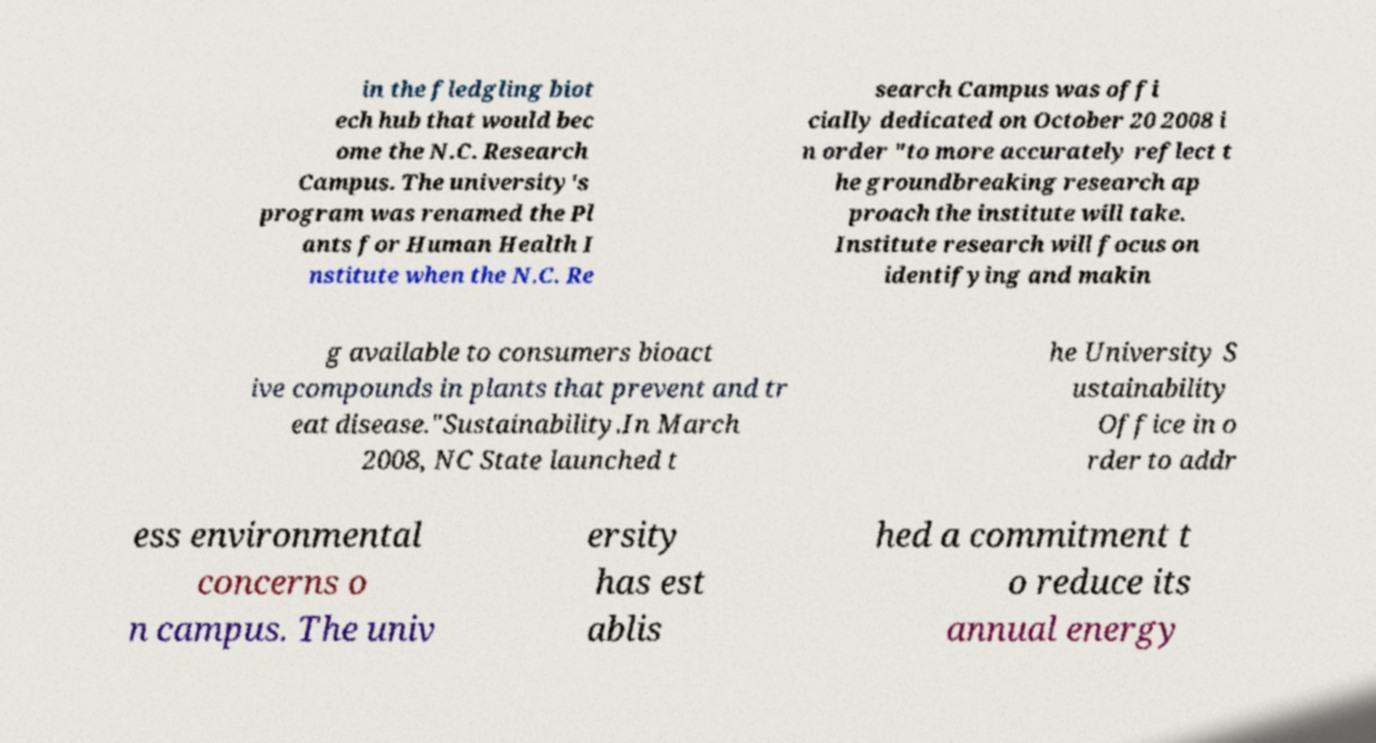For documentation purposes, I need the text within this image transcribed. Could you provide that? in the fledgling biot ech hub that would bec ome the N.C. Research Campus. The university's program was renamed the Pl ants for Human Health I nstitute when the N.C. Re search Campus was offi cially dedicated on October 20 2008 i n order "to more accurately reflect t he groundbreaking research ap proach the institute will take. Institute research will focus on identifying and makin g available to consumers bioact ive compounds in plants that prevent and tr eat disease."Sustainability.In March 2008, NC State launched t he University S ustainability Office in o rder to addr ess environmental concerns o n campus. The univ ersity has est ablis hed a commitment t o reduce its annual energy 